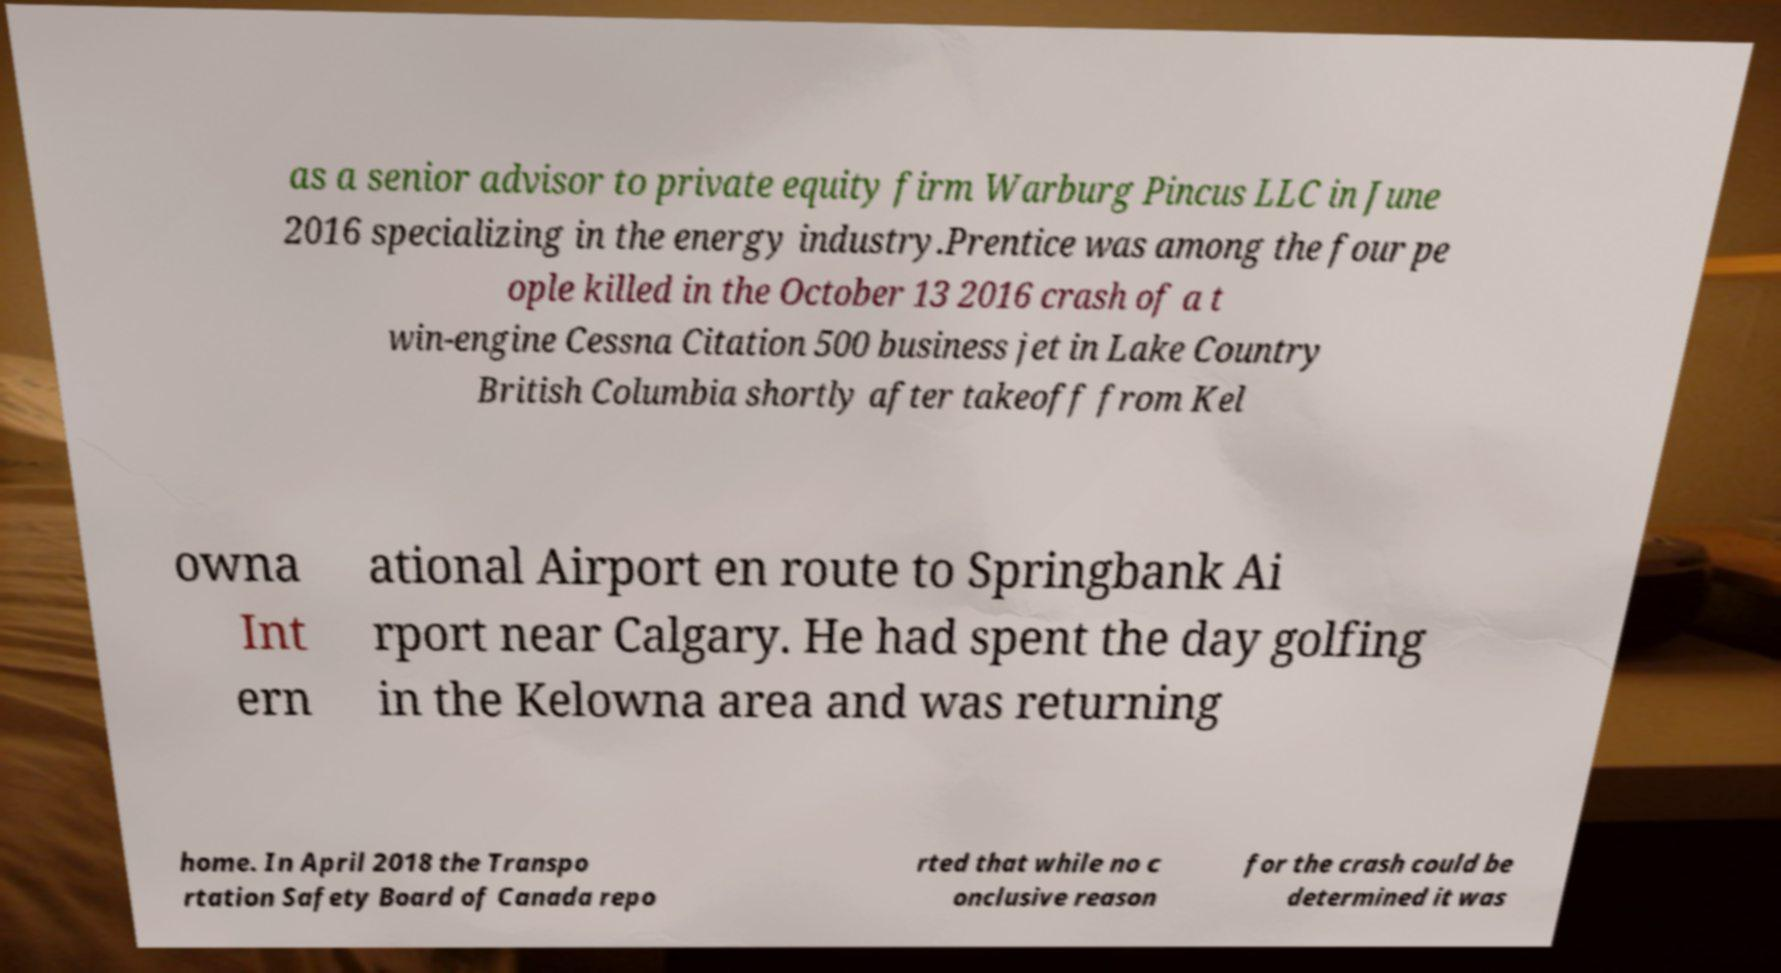Could you extract and type out the text from this image? as a senior advisor to private equity firm Warburg Pincus LLC in June 2016 specializing in the energy industry.Prentice was among the four pe ople killed in the October 13 2016 crash of a t win-engine Cessna Citation 500 business jet in Lake Country British Columbia shortly after takeoff from Kel owna Int ern ational Airport en route to Springbank Ai rport near Calgary. He had spent the day golfing in the Kelowna area and was returning home. In April 2018 the Transpo rtation Safety Board of Canada repo rted that while no c onclusive reason for the crash could be determined it was 